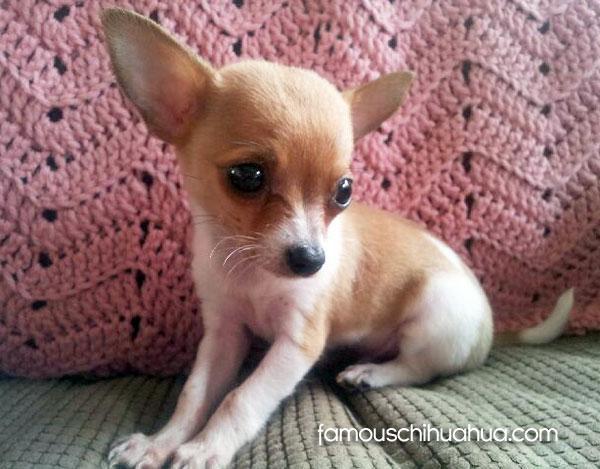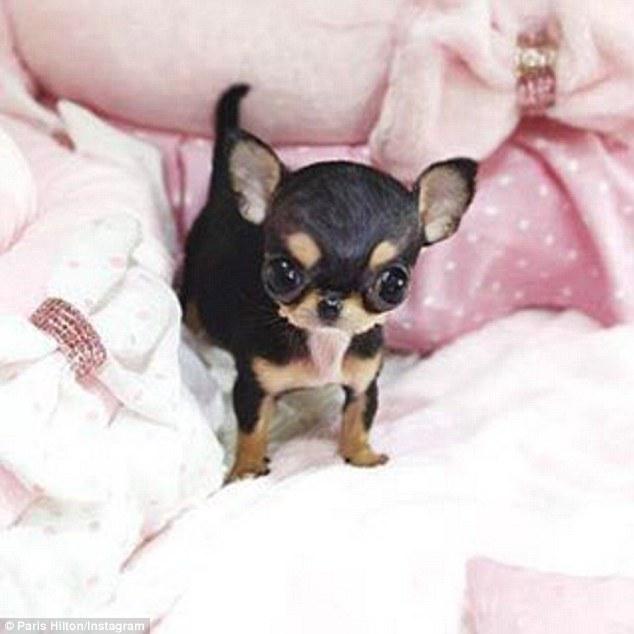The first image is the image on the left, the second image is the image on the right. Evaluate the accuracy of this statement regarding the images: "Someone is holding the dog on the right.". Is it true? Answer yes or no. No. The first image is the image on the left, the second image is the image on the right. Assess this claim about the two images: "An image shows a teacup puppy held by a human hand.". Correct or not? Answer yes or no. No. 